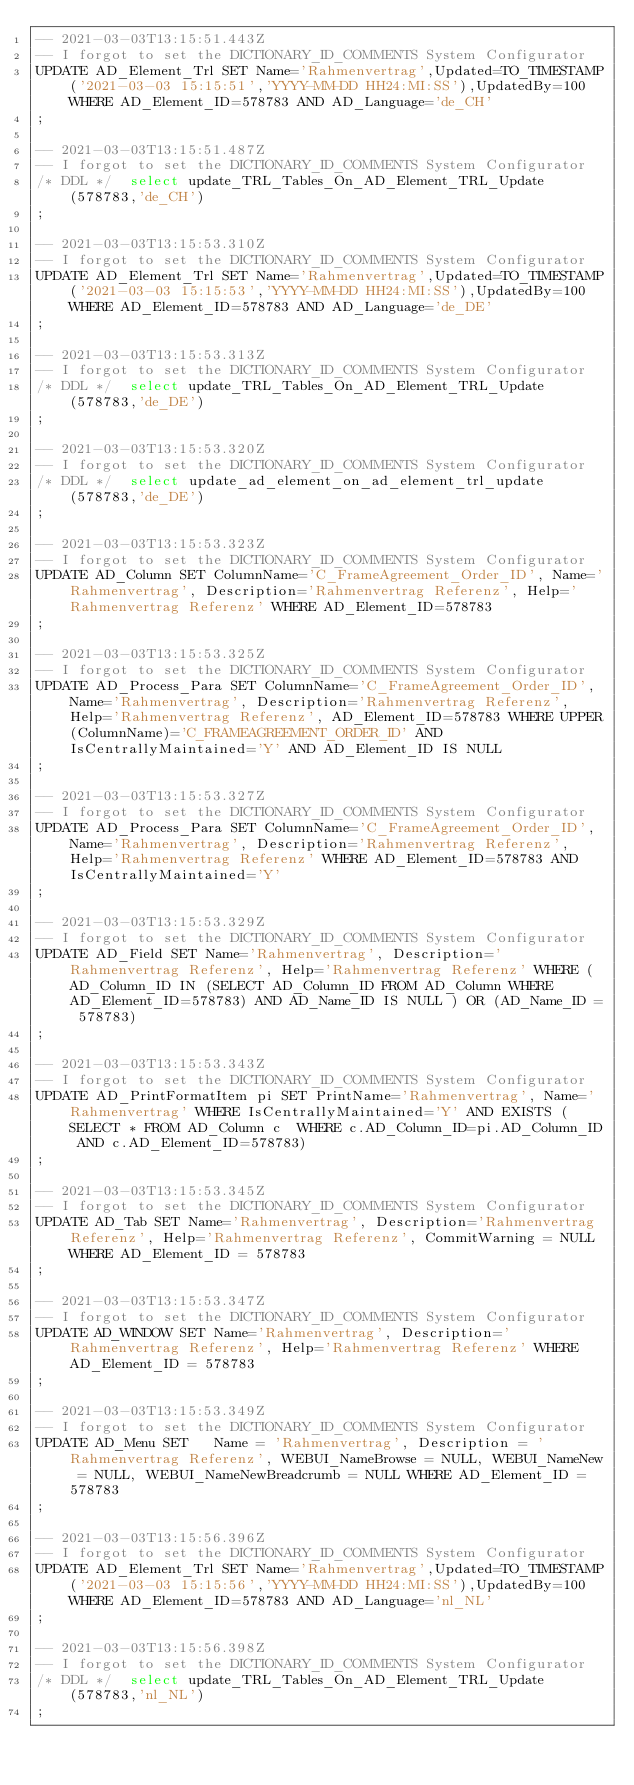Convert code to text. <code><loc_0><loc_0><loc_500><loc_500><_SQL_>-- 2021-03-03T13:15:51.443Z
-- I forgot to set the DICTIONARY_ID_COMMENTS System Configurator
UPDATE AD_Element_Trl SET Name='Rahmenvertrag',Updated=TO_TIMESTAMP('2021-03-03 15:15:51','YYYY-MM-DD HH24:MI:SS'),UpdatedBy=100 WHERE AD_Element_ID=578783 AND AD_Language='de_CH'
;

-- 2021-03-03T13:15:51.487Z
-- I forgot to set the DICTIONARY_ID_COMMENTS System Configurator
/* DDL */  select update_TRL_Tables_On_AD_Element_TRL_Update(578783,'de_CH') 
;

-- 2021-03-03T13:15:53.310Z
-- I forgot to set the DICTIONARY_ID_COMMENTS System Configurator
UPDATE AD_Element_Trl SET Name='Rahmenvertrag',Updated=TO_TIMESTAMP('2021-03-03 15:15:53','YYYY-MM-DD HH24:MI:SS'),UpdatedBy=100 WHERE AD_Element_ID=578783 AND AD_Language='de_DE'
;

-- 2021-03-03T13:15:53.313Z
-- I forgot to set the DICTIONARY_ID_COMMENTS System Configurator
/* DDL */  select update_TRL_Tables_On_AD_Element_TRL_Update(578783,'de_DE') 
;

-- 2021-03-03T13:15:53.320Z
-- I forgot to set the DICTIONARY_ID_COMMENTS System Configurator
/* DDL */  select update_ad_element_on_ad_element_trl_update(578783,'de_DE') 
;

-- 2021-03-03T13:15:53.323Z
-- I forgot to set the DICTIONARY_ID_COMMENTS System Configurator
UPDATE AD_Column SET ColumnName='C_FrameAgreement_Order_ID', Name='Rahmenvertrag', Description='Rahmenvertrag Referenz', Help='Rahmenvertrag Referenz' WHERE AD_Element_ID=578783
;

-- 2021-03-03T13:15:53.325Z
-- I forgot to set the DICTIONARY_ID_COMMENTS System Configurator
UPDATE AD_Process_Para SET ColumnName='C_FrameAgreement_Order_ID', Name='Rahmenvertrag', Description='Rahmenvertrag Referenz', Help='Rahmenvertrag Referenz', AD_Element_ID=578783 WHERE UPPER(ColumnName)='C_FRAMEAGREEMENT_ORDER_ID' AND IsCentrallyMaintained='Y' AND AD_Element_ID IS NULL
;

-- 2021-03-03T13:15:53.327Z
-- I forgot to set the DICTIONARY_ID_COMMENTS System Configurator
UPDATE AD_Process_Para SET ColumnName='C_FrameAgreement_Order_ID', Name='Rahmenvertrag', Description='Rahmenvertrag Referenz', Help='Rahmenvertrag Referenz' WHERE AD_Element_ID=578783 AND IsCentrallyMaintained='Y'
;

-- 2021-03-03T13:15:53.329Z
-- I forgot to set the DICTIONARY_ID_COMMENTS System Configurator
UPDATE AD_Field SET Name='Rahmenvertrag', Description='Rahmenvertrag Referenz', Help='Rahmenvertrag Referenz' WHERE (AD_Column_ID IN (SELECT AD_Column_ID FROM AD_Column WHERE AD_Element_ID=578783) AND AD_Name_ID IS NULL ) OR (AD_Name_ID = 578783)
;

-- 2021-03-03T13:15:53.343Z
-- I forgot to set the DICTIONARY_ID_COMMENTS System Configurator
UPDATE AD_PrintFormatItem pi SET PrintName='Rahmenvertrag', Name='Rahmenvertrag' WHERE IsCentrallyMaintained='Y' AND EXISTS (SELECT * FROM AD_Column c  WHERE c.AD_Column_ID=pi.AD_Column_ID AND c.AD_Element_ID=578783)
;

-- 2021-03-03T13:15:53.345Z
-- I forgot to set the DICTIONARY_ID_COMMENTS System Configurator
UPDATE AD_Tab SET Name='Rahmenvertrag', Description='Rahmenvertrag Referenz', Help='Rahmenvertrag Referenz', CommitWarning = NULL WHERE AD_Element_ID = 578783
;

-- 2021-03-03T13:15:53.347Z
-- I forgot to set the DICTIONARY_ID_COMMENTS System Configurator
UPDATE AD_WINDOW SET Name='Rahmenvertrag', Description='Rahmenvertrag Referenz', Help='Rahmenvertrag Referenz' WHERE AD_Element_ID = 578783
;

-- 2021-03-03T13:15:53.349Z
-- I forgot to set the DICTIONARY_ID_COMMENTS System Configurator
UPDATE AD_Menu SET   Name = 'Rahmenvertrag', Description = 'Rahmenvertrag Referenz', WEBUI_NameBrowse = NULL, WEBUI_NameNew = NULL, WEBUI_NameNewBreadcrumb = NULL WHERE AD_Element_ID = 578783
;

-- 2021-03-03T13:15:56.396Z
-- I forgot to set the DICTIONARY_ID_COMMENTS System Configurator
UPDATE AD_Element_Trl SET Name='Rahmenvertrag',Updated=TO_TIMESTAMP('2021-03-03 15:15:56','YYYY-MM-DD HH24:MI:SS'),UpdatedBy=100 WHERE AD_Element_ID=578783 AND AD_Language='nl_NL'
;

-- 2021-03-03T13:15:56.398Z
-- I forgot to set the DICTIONARY_ID_COMMENTS System Configurator
/* DDL */  select update_TRL_Tables_On_AD_Element_TRL_Update(578783,'nl_NL') 
;

</code> 